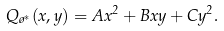<formula> <loc_0><loc_0><loc_500><loc_500>Q _ { \tau ^ { * } } ( x , y ) = A x ^ { 2 } + B x y + C y ^ { 2 } .</formula> 